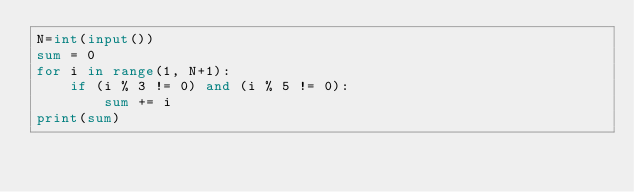<code> <loc_0><loc_0><loc_500><loc_500><_Python_>N=int(input())
sum = 0
for i in range(1, N+1):
    if (i % 3 != 0) and (i % 5 != 0):
        sum += i
print(sum)</code> 